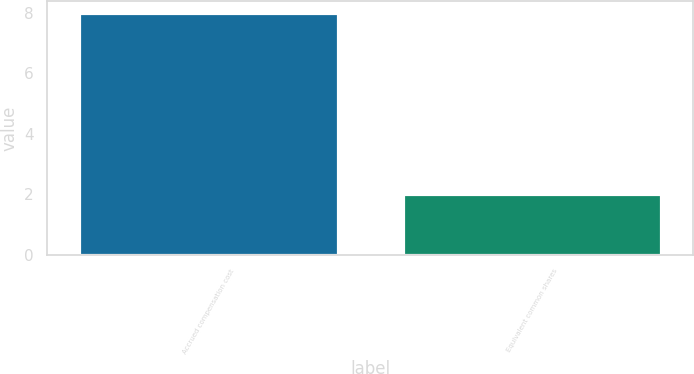<chart> <loc_0><loc_0><loc_500><loc_500><bar_chart><fcel>Accrued compensation cost<fcel>Equivalent common shares<nl><fcel>8<fcel>2<nl></chart> 